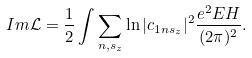Convert formula to latex. <formula><loc_0><loc_0><loc_500><loc_500>I m \mathcal { L } = \frac { 1 } { 2 } \int \sum _ { n , s _ { z } } \ln | c _ { 1 n s _ { z } } | ^ { 2 } \frac { e ^ { 2 } E H } { ( 2 \pi ) ^ { 2 } } .</formula> 